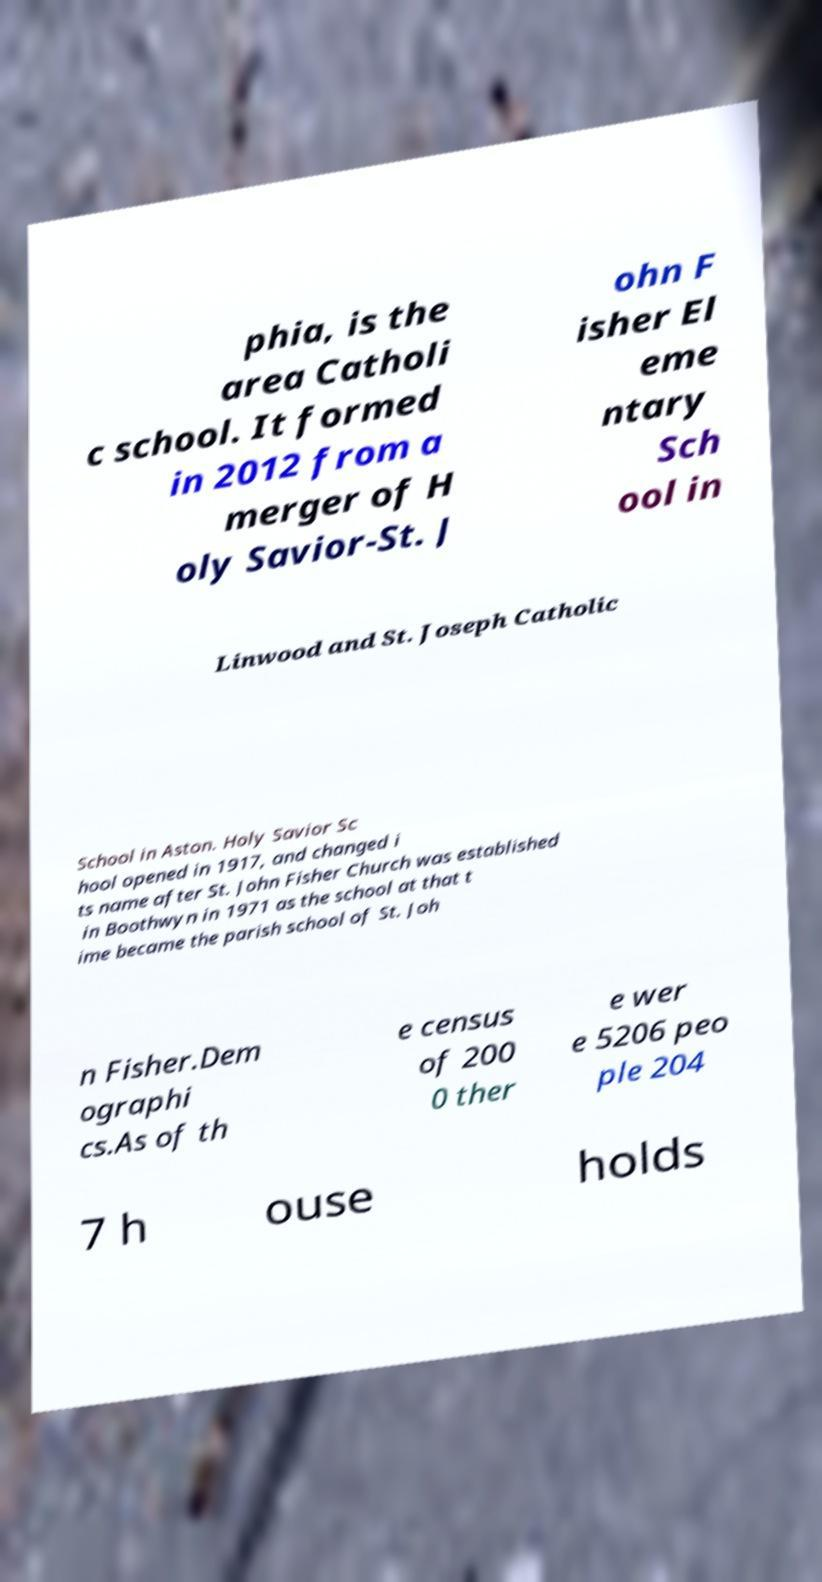Can you read and provide the text displayed in the image?This photo seems to have some interesting text. Can you extract and type it out for me? phia, is the area Catholi c school. It formed in 2012 from a merger of H oly Savior-St. J ohn F isher El eme ntary Sch ool in Linwood and St. Joseph Catholic School in Aston. Holy Savior Sc hool opened in 1917, and changed i ts name after St. John Fisher Church was established in Boothwyn in 1971 as the school at that t ime became the parish school of St. Joh n Fisher.Dem ographi cs.As of th e census of 200 0 ther e wer e 5206 peo ple 204 7 h ouse holds 